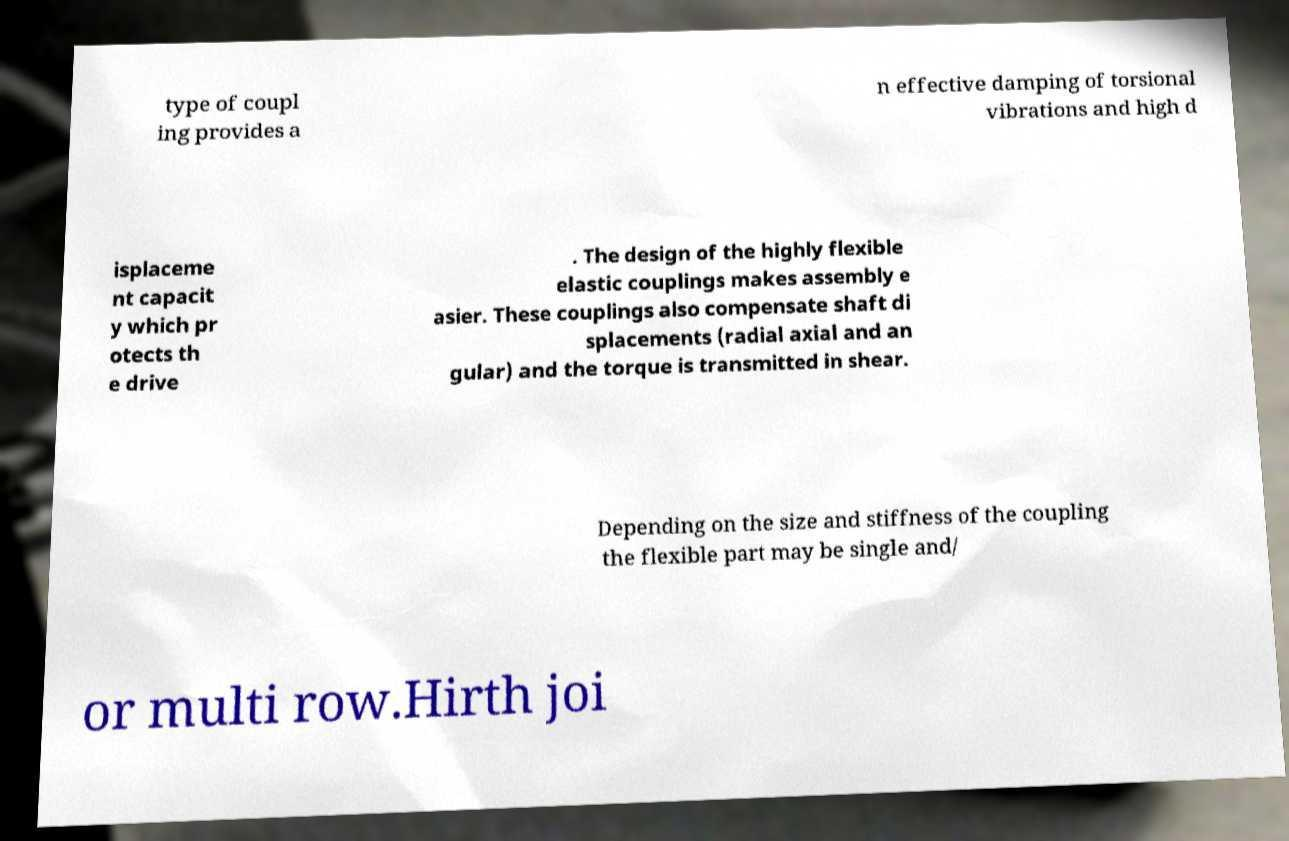For documentation purposes, I need the text within this image transcribed. Could you provide that? type of coupl ing provides a n effective damping of torsional vibrations and high d isplaceme nt capacit y which pr otects th e drive . The design of the highly flexible elastic couplings makes assembly e asier. These couplings also compensate shaft di splacements (radial axial and an gular) and the torque is transmitted in shear. Depending on the size and stiffness of the coupling the flexible part may be single and/ or multi row.Hirth joi 